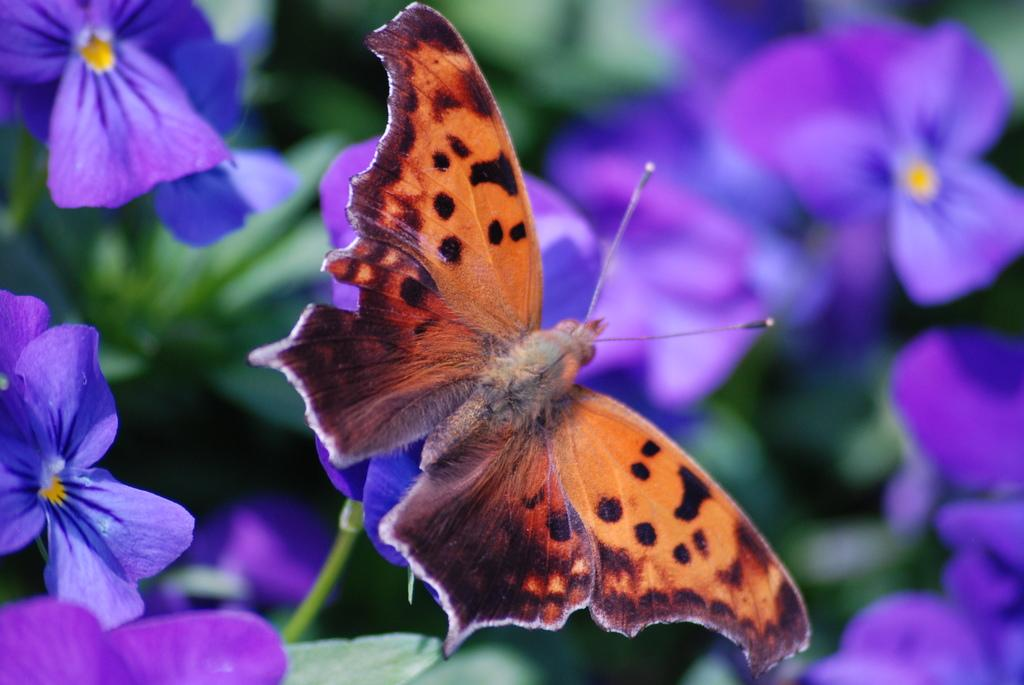What is the main subject of the image? There is a butterfly in the image. Where is the butterfly located in the image? The butterfly is on a flower. Can you describe the background of the image? The background of the image is blurred. How many eyes can be seen on the back of the butterfly in the image? There are no eyes visible on the back of the butterfly in the image, as butterflies have their eyes on the front of their heads. 